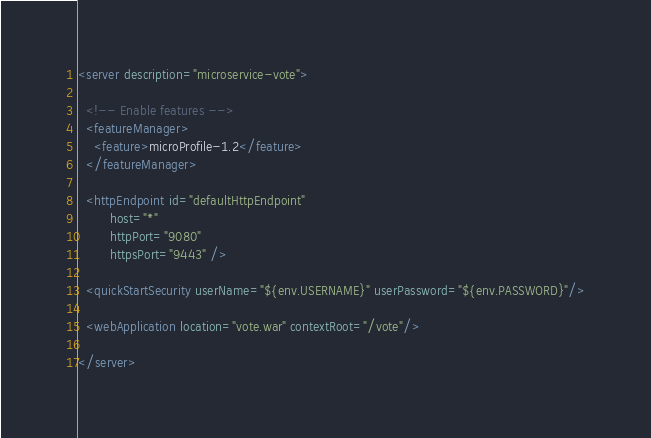Convert code to text. <code><loc_0><loc_0><loc_500><loc_500><_XML_><server description="microservice-vote">

  <!-- Enable features -->
  <featureManager>
    <feature>microProfile-1.2</feature>
  </featureManager>

  <httpEndpoint id="defaultHttpEndpoint"
        host="*"
        httpPort="9080"
        httpsPort="9443" />

  <quickStartSecurity userName="${env.USERNAME}" userPassword="${env.PASSWORD}"/>

  <webApplication location="vote.war" contextRoot="/vote"/>

</server>
</code> 